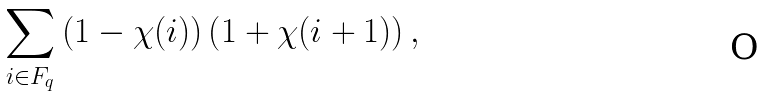<formula> <loc_0><loc_0><loc_500><loc_500>\sum _ { i \in F _ { q } } \left ( 1 - \chi ( i ) \right ) \left ( 1 + \chi ( i + 1 ) \right ) ,</formula> 